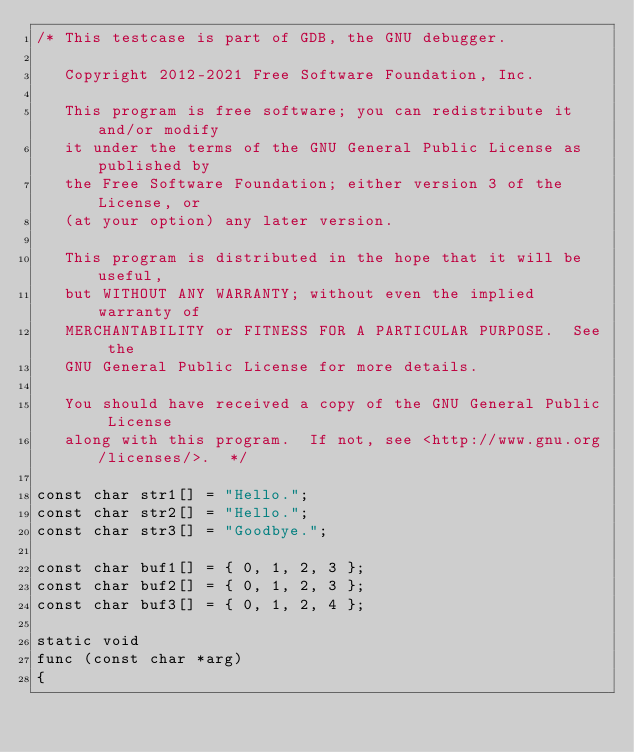<code> <loc_0><loc_0><loc_500><loc_500><_C_>/* This testcase is part of GDB, the GNU debugger.

   Copyright 2012-2021 Free Software Foundation, Inc.

   This program is free software; you can redistribute it and/or modify
   it under the terms of the GNU General Public License as published by
   the Free Software Foundation; either version 3 of the License, or
   (at your option) any later version.

   This program is distributed in the hope that it will be useful,
   but WITHOUT ANY WARRANTY; without even the implied warranty of
   MERCHANTABILITY or FITNESS FOR A PARTICULAR PURPOSE.  See the
   GNU General Public License for more details.

   You should have received a copy of the GNU General Public License
   along with this program.  If not, see <http://www.gnu.org/licenses/>.  */

const char str1[] = "Hello.";
const char str2[] = "Hello.";
const char str3[] = "Goodbye.";

const char buf1[] = { 0, 1, 2, 3 };
const char buf2[] = { 0, 1, 2, 3 };
const char buf3[] = { 0, 1, 2, 4 };

static void
func (const char *arg)
{</code> 